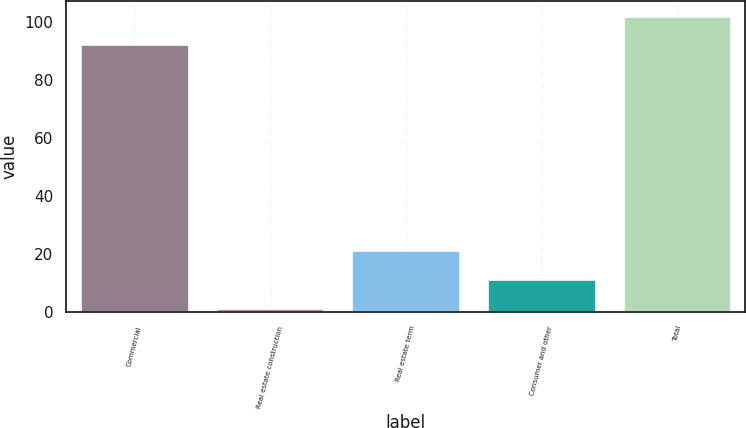Convert chart to OTSL. <chart><loc_0><loc_0><loc_500><loc_500><bar_chart><fcel>Commercial<fcel>Real estate construction<fcel>Real estate term<fcel>Consumer and other<fcel>Total<nl><fcel>92.3<fcel>1.5<fcel>21.2<fcel>11.35<fcel>102.15<nl></chart> 